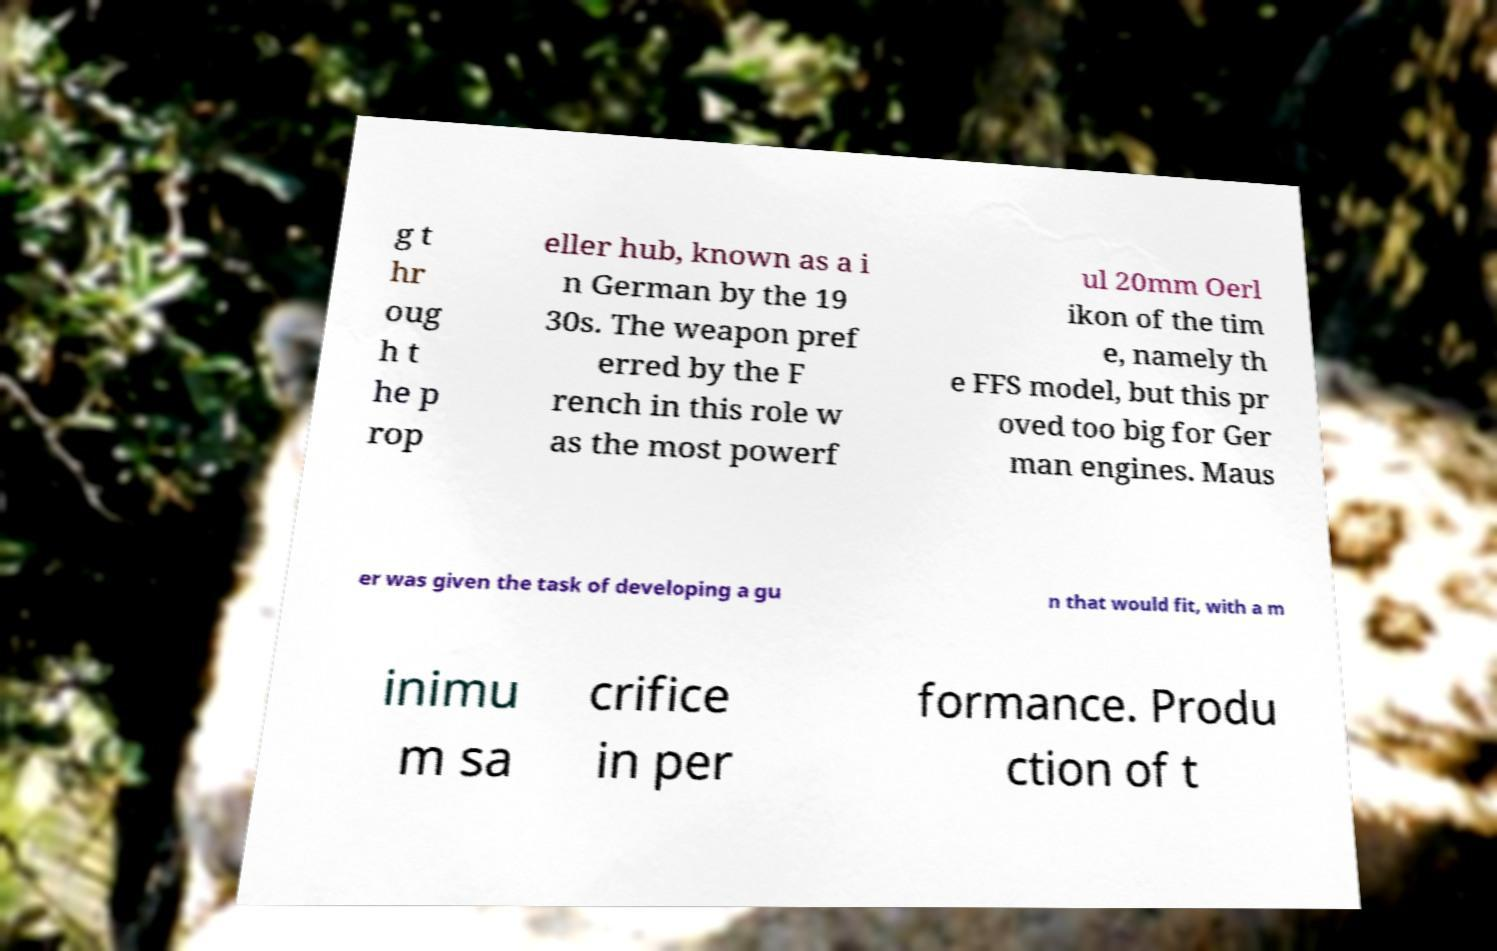Can you accurately transcribe the text from the provided image for me? g t hr oug h t he p rop eller hub, known as a i n German by the 19 30s. The weapon pref erred by the F rench in this role w as the most powerf ul 20mm Oerl ikon of the tim e, namely th e FFS model, but this pr oved too big for Ger man engines. Maus er was given the task of developing a gu n that would fit, with a m inimu m sa crifice in per formance. Produ ction of t 